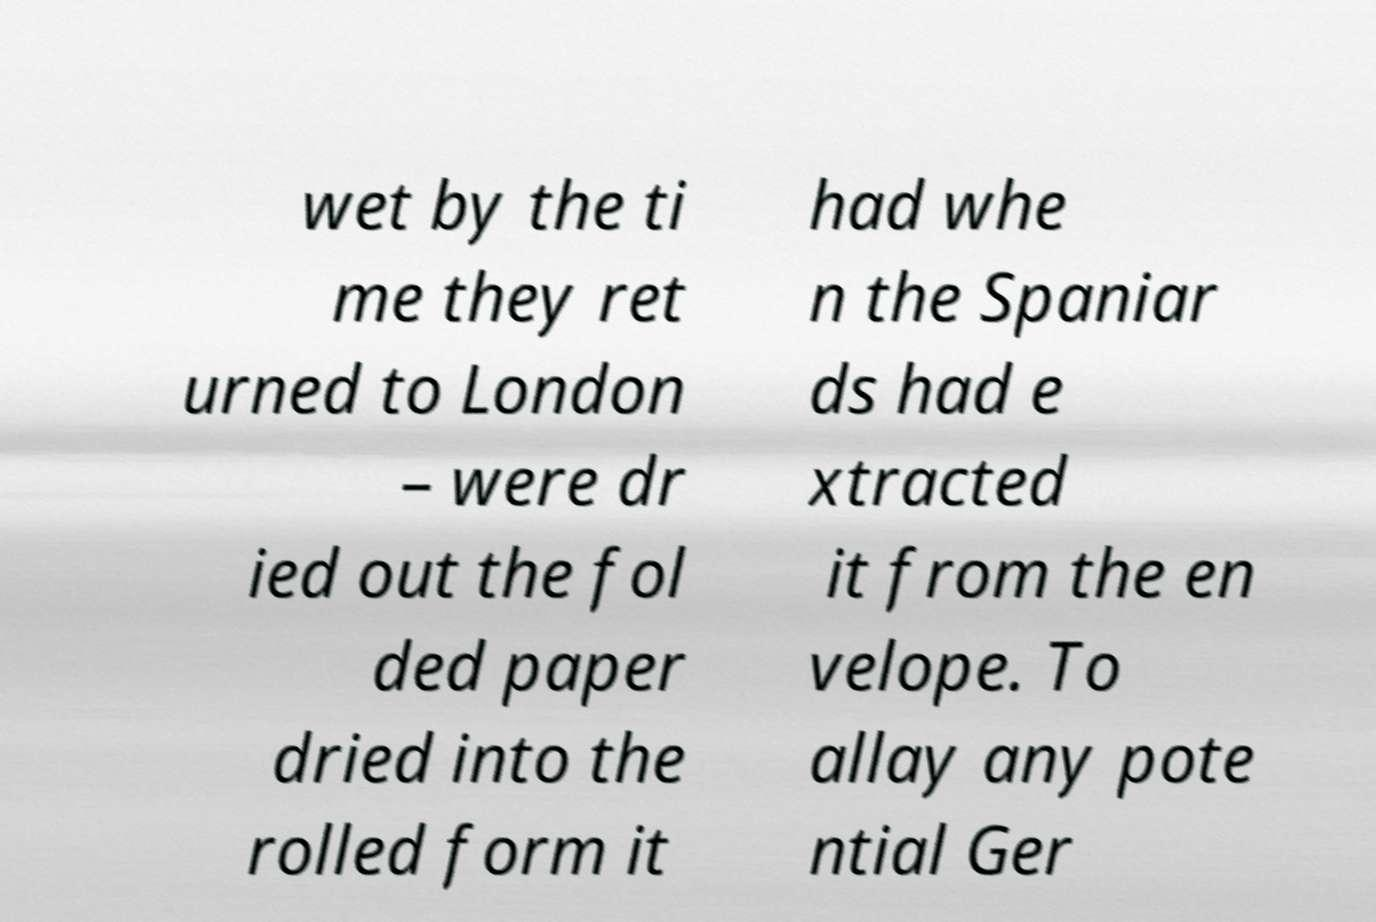Please read and relay the text visible in this image. What does it say? wet by the ti me they ret urned to London – were dr ied out the fol ded paper dried into the rolled form it had whe n the Spaniar ds had e xtracted it from the en velope. To allay any pote ntial Ger 